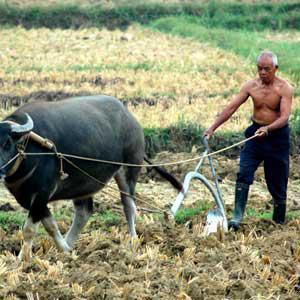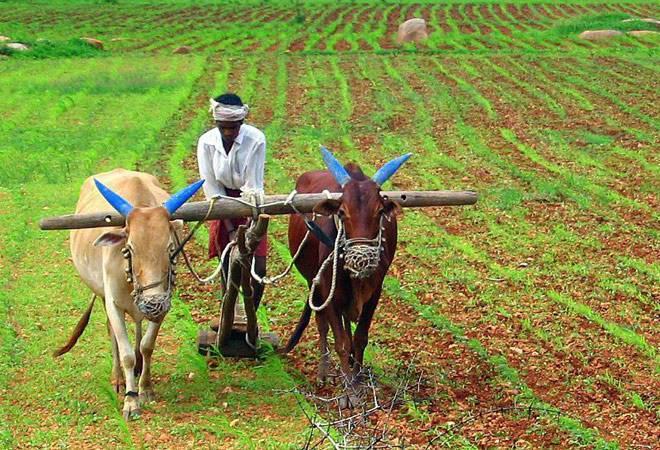The first image is the image on the left, the second image is the image on the right. For the images displayed, is the sentence "Ox are pulling a cart with wheels." factually correct? Answer yes or no. No. The first image is the image on the left, the second image is the image on the right. Considering the images on both sides, is "One image shows two oxen pulling a two-wheeled cart forward on a road, and the other image shows a man standing behind a team of two oxen pulling a plow on a dirt-turned field." valid? Answer yes or no. No. 